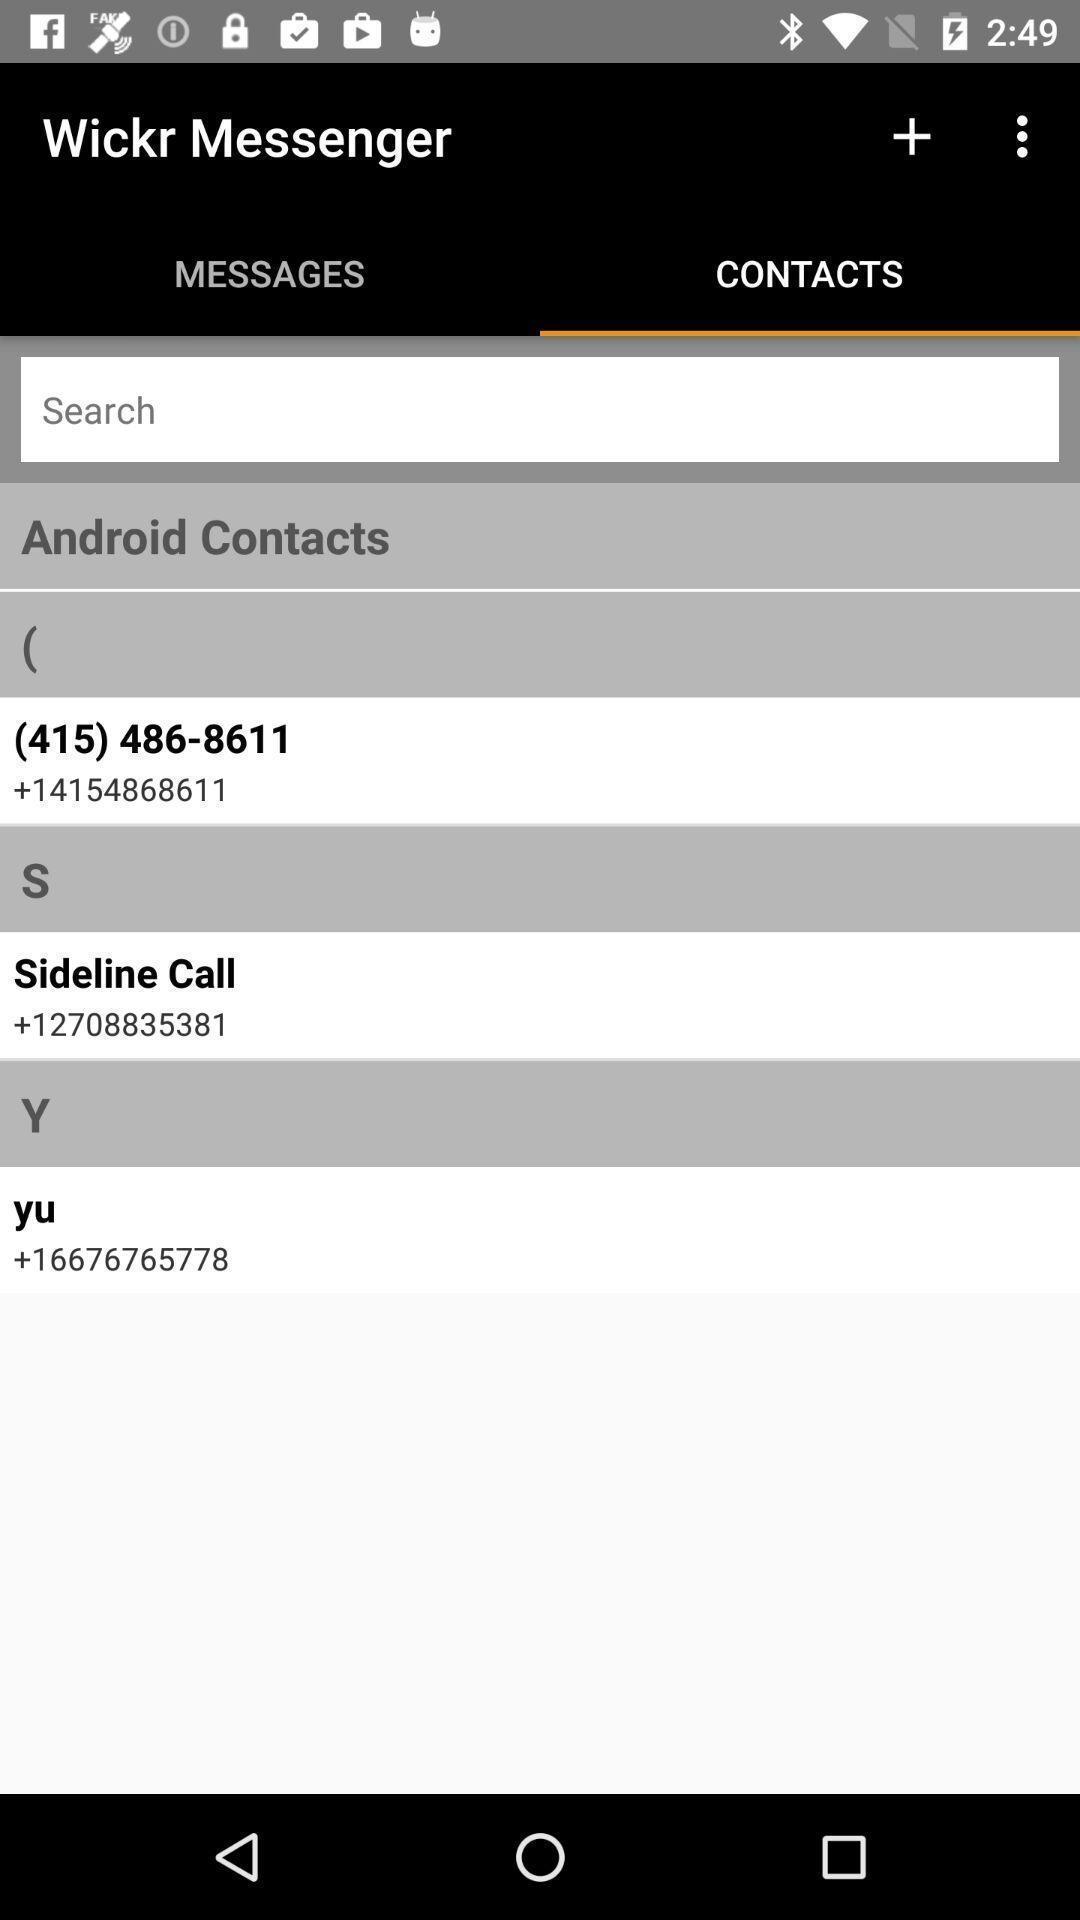Tell me about the visual elements in this screen capture. Page showing the contact listings. 